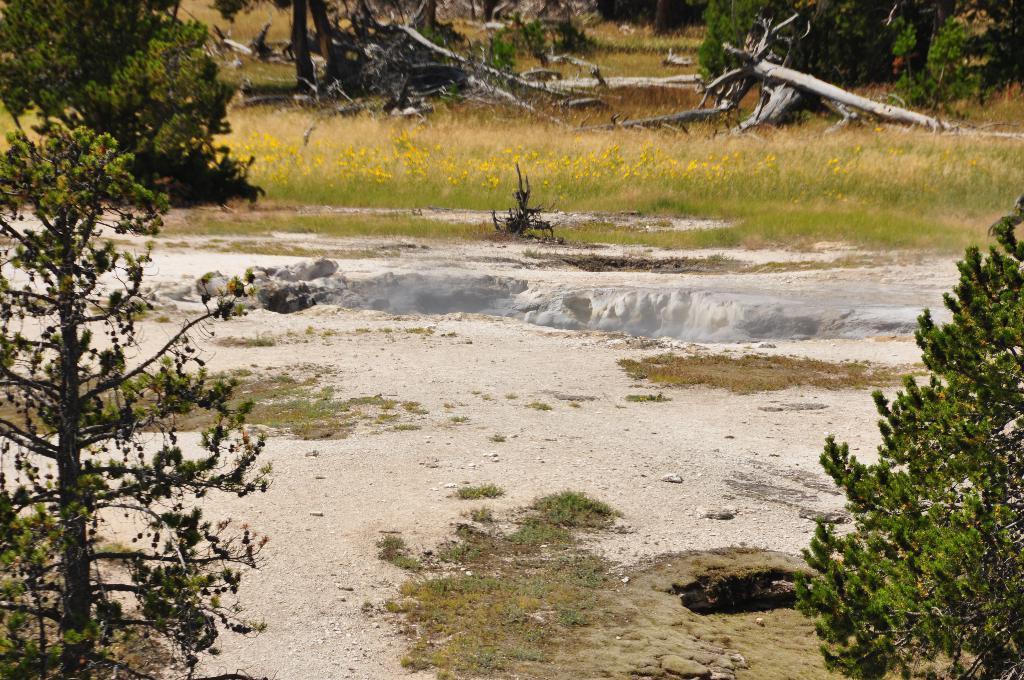Describe this image in one or two sentences. In the foreground of the picture there are trees, grass and soil. In the center of the picture it looks like there is a pit. In the background there are trees, plants, wooden logs, grass and flowers. 